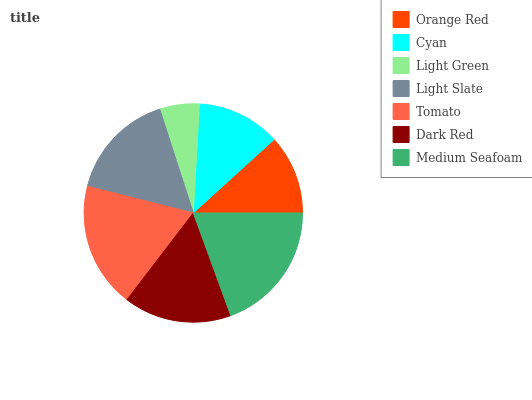Is Light Green the minimum?
Answer yes or no. Yes. Is Medium Seafoam the maximum?
Answer yes or no. Yes. Is Cyan the minimum?
Answer yes or no. No. Is Cyan the maximum?
Answer yes or no. No. Is Cyan greater than Orange Red?
Answer yes or no. Yes. Is Orange Red less than Cyan?
Answer yes or no. Yes. Is Orange Red greater than Cyan?
Answer yes or no. No. Is Cyan less than Orange Red?
Answer yes or no. No. Is Dark Red the high median?
Answer yes or no. Yes. Is Dark Red the low median?
Answer yes or no. Yes. Is Orange Red the high median?
Answer yes or no. No. Is Tomato the low median?
Answer yes or no. No. 